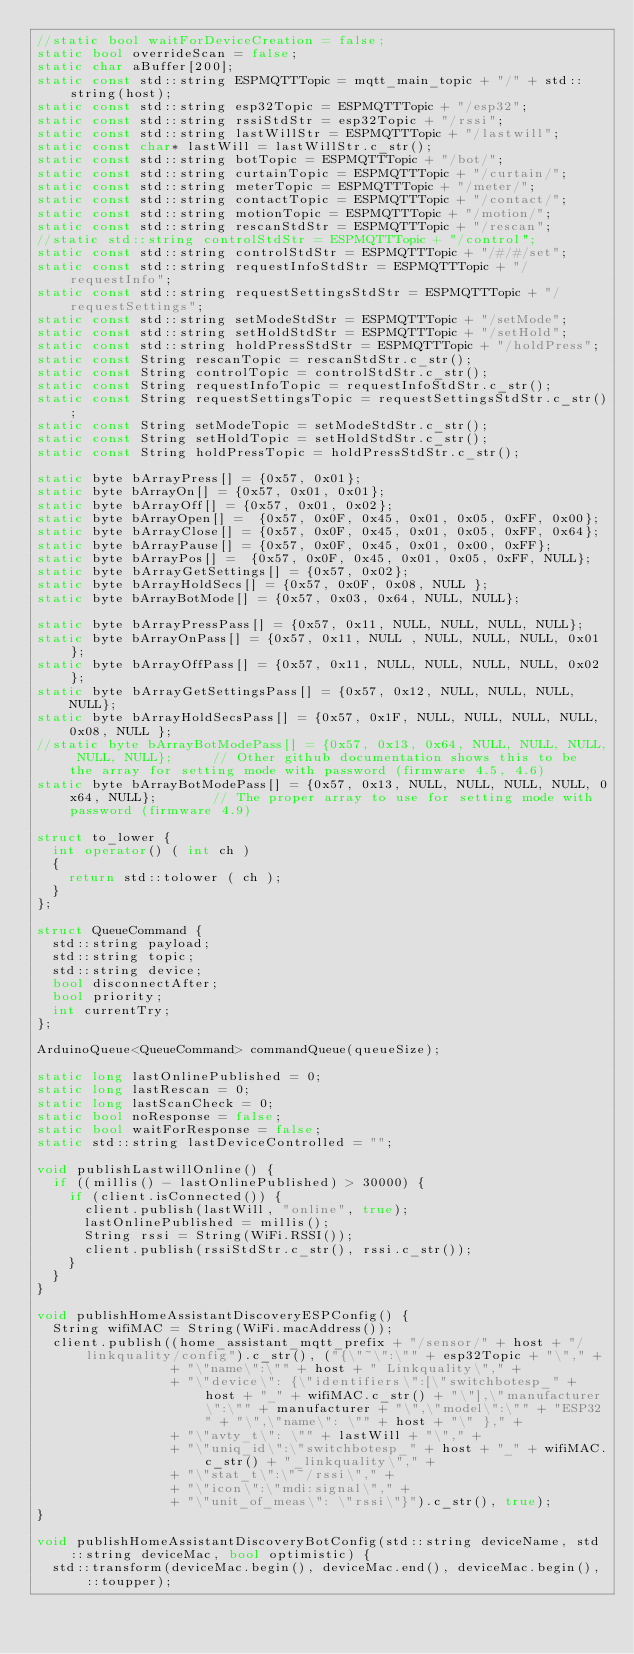<code> <loc_0><loc_0><loc_500><loc_500><_C++_>//static bool waitForDeviceCreation = false;
static bool overrideScan = false;
static char aBuffer[200];
static const std::string ESPMQTTTopic = mqtt_main_topic + "/" + std::string(host);
static const std::string esp32Topic = ESPMQTTTopic + "/esp32";
static const std::string rssiStdStr = esp32Topic + "/rssi";
static const std::string lastWillStr = ESPMQTTTopic + "/lastwill";
static const char* lastWill = lastWillStr.c_str();
static const std::string botTopic = ESPMQTTTopic + "/bot/";
static const std::string curtainTopic = ESPMQTTTopic + "/curtain/";
static const std::string meterTopic = ESPMQTTTopic + "/meter/";
static const std::string contactTopic = ESPMQTTTopic + "/contact/";
static const std::string motionTopic = ESPMQTTTopic + "/motion/";
static const std::string rescanStdStr = ESPMQTTTopic + "/rescan";
//static std::string controlStdStr = ESPMQTTTopic + "/control";
static const std::string controlStdStr = ESPMQTTTopic + "/#/#/set";
static const std::string requestInfoStdStr = ESPMQTTTopic + "/requestInfo";
static const std::string requestSettingsStdStr = ESPMQTTTopic + "/requestSettings";
static const std::string setModeStdStr = ESPMQTTTopic + "/setMode";
static const std::string setHoldStdStr = ESPMQTTTopic + "/setHold";
static const std::string holdPressStdStr = ESPMQTTTopic + "/holdPress";
static const String rescanTopic = rescanStdStr.c_str();
static const String controlTopic = controlStdStr.c_str();
static const String requestInfoTopic = requestInfoStdStr.c_str();
static const String requestSettingsTopic = requestSettingsStdStr.c_str();
static const String setModeTopic = setModeStdStr.c_str();
static const String setHoldTopic = setHoldStdStr.c_str();
static const String holdPressTopic = holdPressStdStr.c_str();

static byte bArrayPress[] = {0x57, 0x01};
static byte bArrayOn[] = {0x57, 0x01, 0x01};
static byte bArrayOff[] = {0x57, 0x01, 0x02};
static byte bArrayOpen[] =  {0x57, 0x0F, 0x45, 0x01, 0x05, 0xFF, 0x00};
static byte bArrayClose[] = {0x57, 0x0F, 0x45, 0x01, 0x05, 0xFF, 0x64};
static byte bArrayPause[] = {0x57, 0x0F, 0x45, 0x01, 0x00, 0xFF};
static byte bArrayPos[] =  {0x57, 0x0F, 0x45, 0x01, 0x05, 0xFF, NULL};
static byte bArrayGetSettings[] = {0x57, 0x02};
static byte bArrayHoldSecs[] = {0x57, 0x0F, 0x08, NULL };
static byte bArrayBotMode[] = {0x57, 0x03, 0x64, NULL, NULL};

static byte bArrayPressPass[] = {0x57, 0x11, NULL, NULL, NULL, NULL};
static byte bArrayOnPass[] = {0x57, 0x11, NULL , NULL, NULL, NULL, 0x01};
static byte bArrayOffPass[] = {0x57, 0x11, NULL, NULL, NULL, NULL, 0x02};
static byte bArrayGetSettingsPass[] = {0x57, 0x12, NULL, NULL, NULL, NULL};
static byte bArrayHoldSecsPass[] = {0x57, 0x1F, NULL, NULL, NULL, NULL, 0x08, NULL };
//static byte bArrayBotModePass[] = {0x57, 0x13, 0x64, NULL, NULL, NULL, NULL, NULL};     // Other github documentation shows this to be the array for setting mode with password (firmware 4.5, 4.6)
static byte bArrayBotModePass[] = {0x57, 0x13, NULL, NULL, NULL, NULL, 0x64, NULL};       // The proper array to use for setting mode with password (firmware 4.9)

struct to_lower {
  int operator() ( int ch )
  {
    return std::tolower ( ch );
  }
};

struct QueueCommand {
  std::string payload;
  std::string topic;
  std::string device;
  bool disconnectAfter;
  bool priority;
  int currentTry;
};

ArduinoQueue<QueueCommand> commandQueue(queueSize);

static long lastOnlinePublished = 0;
static long lastRescan = 0;
static long lastScanCheck = 0;
static bool noResponse = false;
static bool waitForResponse = false;
static std::string lastDeviceControlled = "";

void publishLastwillOnline() {
  if ((millis() - lastOnlinePublished) > 30000) {
    if (client.isConnected()) {
      client.publish(lastWill, "online", true);
      lastOnlinePublished = millis();
      String rssi = String(WiFi.RSSI());
      client.publish(rssiStdStr.c_str(), rssi.c_str());
    }
  }
}

void publishHomeAssistantDiscoveryESPConfig() {
  String wifiMAC = String(WiFi.macAddress());
  client.publish((home_assistant_mqtt_prefix + "/sensor/" + host + "/linkquality/config").c_str(), ("{\"~\":\"" + esp32Topic + "\"," +
                 + "\"name\":\"" + host + " Linkquality\"," +
                 + "\"device\": {\"identifiers\":[\"switchbotesp_" + host + "_" + wifiMAC.c_str() + "\"],\"manufacturer\":\"" + manufacturer + "\",\"model\":\"" + "ESP32" + "\",\"name\": \"" + host + "\" }," +
                 + "\"avty_t\": \"" + lastWill + "\"," +
                 + "\"uniq_id\":\"switchbotesp_" + host + "_" + wifiMAC.c_str() + "_linkquality\"," +
                 + "\"stat_t\":\"~/rssi\"," +
                 + "\"icon\":\"mdi:signal\"," +
                 + "\"unit_of_meas\": \"rssi\"}").c_str(), true);
}

void publishHomeAssistantDiscoveryBotConfig(std::string deviceName, std::string deviceMac, bool optimistic) {
  std::transform(deviceMac.begin(), deviceMac.end(), deviceMac.begin(), ::toupper);</code> 